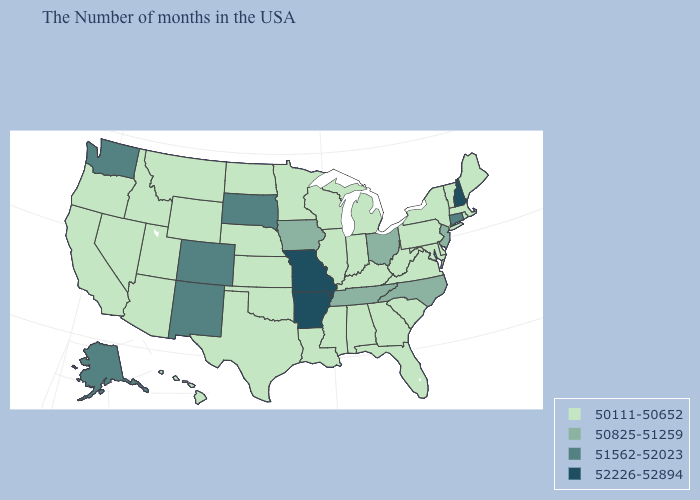Is the legend a continuous bar?
Give a very brief answer. No. Among the states that border South Carolina , which have the lowest value?
Answer briefly. Georgia. What is the value of Kansas?
Concise answer only. 50111-50652. Which states have the highest value in the USA?
Short answer required. New Hampshire, Missouri, Arkansas. Does Texas have a lower value than Tennessee?
Write a very short answer. Yes. What is the value of West Virginia?
Short answer required. 50111-50652. How many symbols are there in the legend?
Write a very short answer. 4. How many symbols are there in the legend?
Write a very short answer. 4. Does South Carolina have a lower value than New Hampshire?
Be succinct. Yes. What is the value of Arkansas?
Give a very brief answer. 52226-52894. Which states hav the highest value in the Northeast?
Write a very short answer. New Hampshire. Is the legend a continuous bar?
Quick response, please. No. What is the lowest value in states that border Ohio?
Write a very short answer. 50111-50652. Does Wisconsin have a lower value than Maryland?
Give a very brief answer. No. 